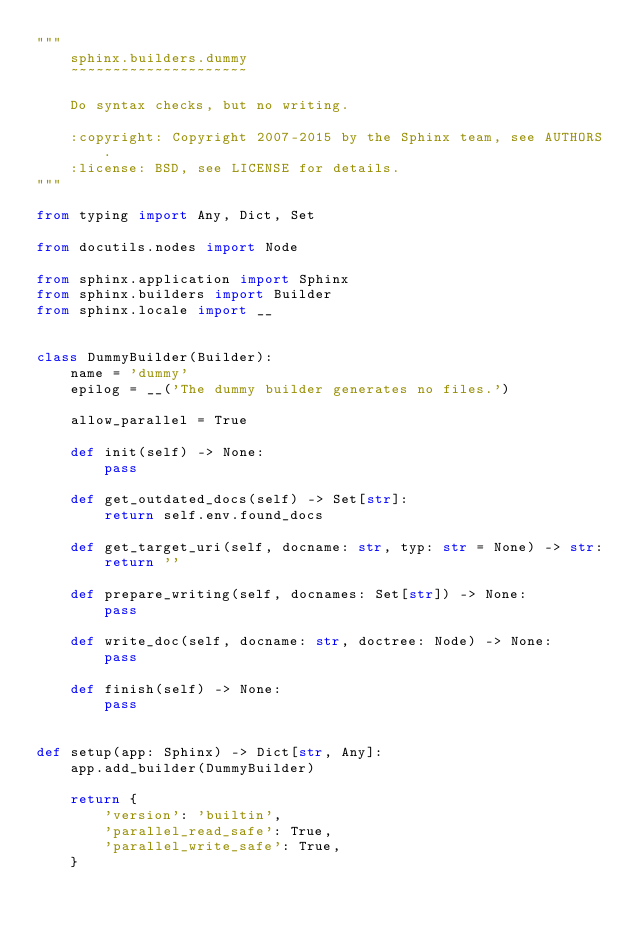<code> <loc_0><loc_0><loc_500><loc_500><_Python_>"""
    sphinx.builders.dummy
    ~~~~~~~~~~~~~~~~~~~~~

    Do syntax checks, but no writing.

    :copyright: Copyright 2007-2015 by the Sphinx team, see AUTHORS.
    :license: BSD, see LICENSE for details.
"""

from typing import Any, Dict, Set

from docutils.nodes import Node

from sphinx.application import Sphinx
from sphinx.builders import Builder
from sphinx.locale import __


class DummyBuilder(Builder):
    name = 'dummy'
    epilog = __('The dummy builder generates no files.')

    allow_parallel = True

    def init(self) -> None:
        pass

    def get_outdated_docs(self) -> Set[str]:
        return self.env.found_docs

    def get_target_uri(self, docname: str, typ: str = None) -> str:
        return ''

    def prepare_writing(self, docnames: Set[str]) -> None:
        pass

    def write_doc(self, docname: str, doctree: Node) -> None:
        pass

    def finish(self) -> None:
        pass


def setup(app: Sphinx) -> Dict[str, Any]:
    app.add_builder(DummyBuilder)

    return {
        'version': 'builtin',
        'parallel_read_safe': True,
        'parallel_write_safe': True,
    }
</code> 